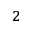Convert formula to latex. <formula><loc_0><loc_0><loc_500><loc_500>^ { 2 }</formula> 